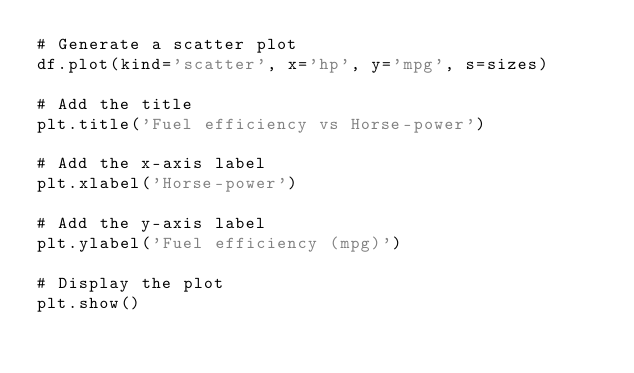Convert code to text. <code><loc_0><loc_0><loc_500><loc_500><_Python_># Generate a scatter plot
df.plot(kind='scatter', x='hp', y='mpg', s=sizes)

# Add the title
plt.title('Fuel efficiency vs Horse-power')

# Add the x-axis label
plt.xlabel('Horse-power')

# Add the y-axis label
plt.ylabel('Fuel efficiency (mpg)')

# Display the plot
plt.show()
</code> 